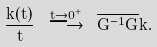<formula> <loc_0><loc_0><loc_500><loc_500>\frac { k ( t ) } { t } \ \stackrel { t \to 0 ^ { + } } { \longrightarrow } \ \overline { G ^ { - 1 } G } k .</formula> 